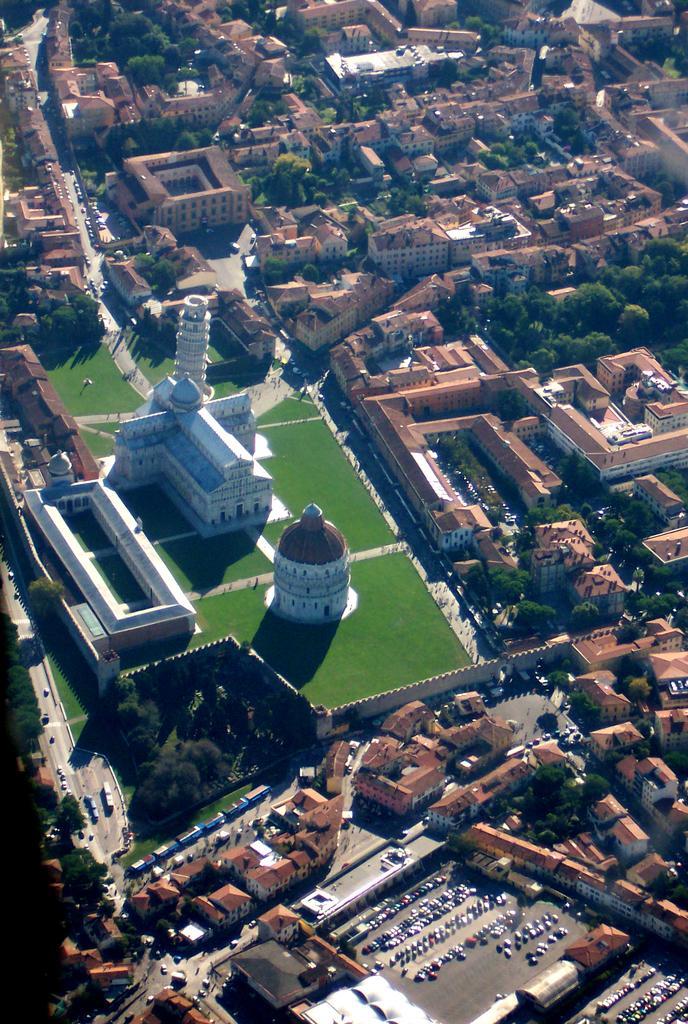Describe this image in one or two sentences. It is the aerial view of a city, it has many buildings and houses, rhoades, garden and a lot of trees. 